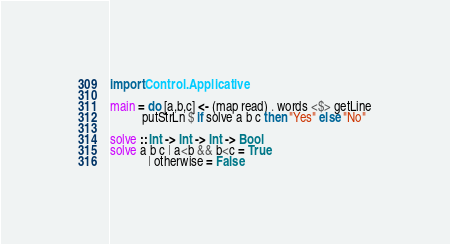<code> <loc_0><loc_0><loc_500><loc_500><_Haskell_>import Control.Applicative

main = do [a,b,c] <- (map read) . words <$> getLine
          putStrLn $ if solve a b c then "Yes" else "No"

solve :: Int -> Int -> Int -> Bool
solve a b c | a<b && b<c = True
            | otherwise = False</code> 